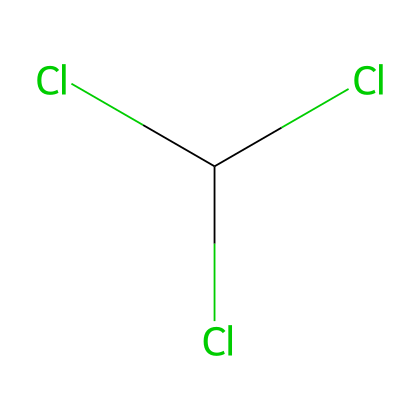What is the chemical name of this compound? The SMILES representation indicates the presence of a carbon atom (C) bonded with three chlorine atoms (Cl), leading to the chemical name chloroform.
Answer: chloroform How many chlorine atoms are present in this structure? The SMILES representation shows three chlorine atoms (Cl) connected to the central carbon atom (C). Therefore, there are three chlorine atoms.
Answer: three What is the number of carbon atoms in chloroform? The SMILES representation indicates that there is a single carbon atom (C) present as the central atom in the structure of chloroform.
Answer: one What type of bond connects the carbon and chlorine atoms in this compound? The SMILES representation implies single covalent bonds between the carbon atom (C) and each chlorine atom (Cl), as indicated by the lack of any other bond type symbols.
Answer: single covalent Is chloroform considered a hazardous material? Due to its toxic and potentially carcinogenic properties, chloroform is classified as a hazardous material.
Answer: yes What is the historical context of chloroform in medicine? Chloroform was widely used in the 19th century as an anesthetic during surgeries, making it significant in medical history.
Answer: anesthetic What functional group is associated with chloroform? The presence of multiple halogen atoms (chlorine) attached to the carbon indicates that chloroform belongs to the class of halogenated hydrocarbons.
Answer: halogenated hydrocarbon 